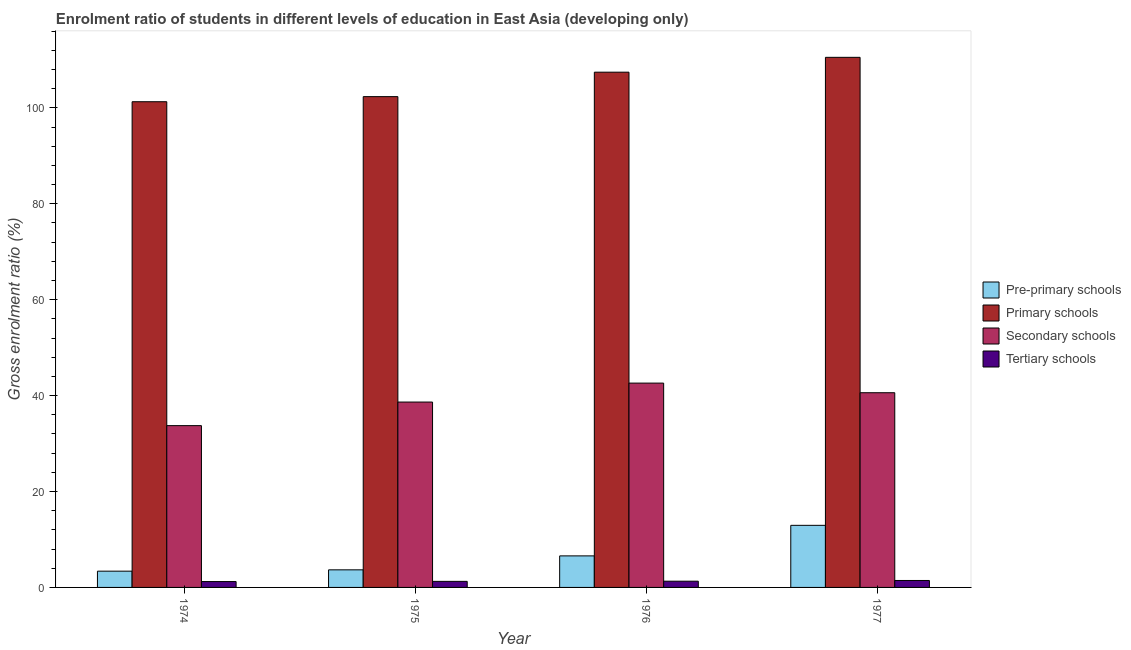How many different coloured bars are there?
Make the answer very short. 4. How many groups of bars are there?
Make the answer very short. 4. Are the number of bars per tick equal to the number of legend labels?
Ensure brevity in your answer.  Yes. Are the number of bars on each tick of the X-axis equal?
Your answer should be very brief. Yes. How many bars are there on the 4th tick from the left?
Provide a succinct answer. 4. What is the label of the 3rd group of bars from the left?
Provide a short and direct response. 1976. What is the gross enrolment ratio in pre-primary schools in 1977?
Give a very brief answer. 12.95. Across all years, what is the maximum gross enrolment ratio in tertiary schools?
Keep it short and to the point. 1.45. Across all years, what is the minimum gross enrolment ratio in pre-primary schools?
Keep it short and to the point. 3.39. In which year was the gross enrolment ratio in primary schools minimum?
Ensure brevity in your answer.  1974. What is the total gross enrolment ratio in pre-primary schools in the graph?
Provide a succinct answer. 26.59. What is the difference between the gross enrolment ratio in primary schools in 1975 and that in 1976?
Make the answer very short. -5.1. What is the difference between the gross enrolment ratio in tertiary schools in 1977 and the gross enrolment ratio in primary schools in 1975?
Ensure brevity in your answer.  0.19. What is the average gross enrolment ratio in pre-primary schools per year?
Offer a very short reply. 6.65. In how many years, is the gross enrolment ratio in primary schools greater than 88 %?
Provide a short and direct response. 4. What is the ratio of the gross enrolment ratio in primary schools in 1974 to that in 1977?
Provide a short and direct response. 0.92. Is the gross enrolment ratio in secondary schools in 1974 less than that in 1976?
Give a very brief answer. Yes. What is the difference between the highest and the second highest gross enrolment ratio in pre-primary schools?
Your response must be concise. 6.37. What is the difference between the highest and the lowest gross enrolment ratio in tertiary schools?
Your response must be concise. 0.22. Is the sum of the gross enrolment ratio in pre-primary schools in 1976 and 1977 greater than the maximum gross enrolment ratio in secondary schools across all years?
Ensure brevity in your answer.  Yes. Is it the case that in every year, the sum of the gross enrolment ratio in pre-primary schools and gross enrolment ratio in primary schools is greater than the sum of gross enrolment ratio in tertiary schools and gross enrolment ratio in secondary schools?
Provide a short and direct response. No. What does the 2nd bar from the left in 1977 represents?
Ensure brevity in your answer.  Primary schools. What does the 2nd bar from the right in 1974 represents?
Your answer should be very brief. Secondary schools. Is it the case that in every year, the sum of the gross enrolment ratio in pre-primary schools and gross enrolment ratio in primary schools is greater than the gross enrolment ratio in secondary schools?
Ensure brevity in your answer.  Yes. What is the difference between two consecutive major ticks on the Y-axis?
Make the answer very short. 20. Where does the legend appear in the graph?
Provide a succinct answer. Center right. How are the legend labels stacked?
Provide a succinct answer. Vertical. What is the title of the graph?
Your answer should be very brief. Enrolment ratio of students in different levels of education in East Asia (developing only). Does "Structural Policies" appear as one of the legend labels in the graph?
Provide a short and direct response. No. What is the label or title of the Y-axis?
Provide a short and direct response. Gross enrolment ratio (%). What is the Gross enrolment ratio (%) in Pre-primary schools in 1974?
Make the answer very short. 3.39. What is the Gross enrolment ratio (%) of Primary schools in 1974?
Your response must be concise. 101.29. What is the Gross enrolment ratio (%) in Secondary schools in 1974?
Keep it short and to the point. 33.74. What is the Gross enrolment ratio (%) in Tertiary schools in 1974?
Your answer should be very brief. 1.22. What is the Gross enrolment ratio (%) of Pre-primary schools in 1975?
Provide a short and direct response. 3.67. What is the Gross enrolment ratio (%) in Primary schools in 1975?
Provide a succinct answer. 102.35. What is the Gross enrolment ratio (%) in Secondary schools in 1975?
Your answer should be compact. 38.66. What is the Gross enrolment ratio (%) in Tertiary schools in 1975?
Keep it short and to the point. 1.26. What is the Gross enrolment ratio (%) of Pre-primary schools in 1976?
Provide a succinct answer. 6.58. What is the Gross enrolment ratio (%) in Primary schools in 1976?
Make the answer very short. 107.45. What is the Gross enrolment ratio (%) in Secondary schools in 1976?
Provide a short and direct response. 42.61. What is the Gross enrolment ratio (%) in Tertiary schools in 1976?
Offer a terse response. 1.3. What is the Gross enrolment ratio (%) of Pre-primary schools in 1977?
Offer a terse response. 12.95. What is the Gross enrolment ratio (%) of Primary schools in 1977?
Make the answer very short. 110.55. What is the Gross enrolment ratio (%) of Secondary schools in 1977?
Provide a succinct answer. 40.6. What is the Gross enrolment ratio (%) in Tertiary schools in 1977?
Ensure brevity in your answer.  1.45. Across all years, what is the maximum Gross enrolment ratio (%) of Pre-primary schools?
Provide a succinct answer. 12.95. Across all years, what is the maximum Gross enrolment ratio (%) in Primary schools?
Provide a short and direct response. 110.55. Across all years, what is the maximum Gross enrolment ratio (%) of Secondary schools?
Your answer should be very brief. 42.61. Across all years, what is the maximum Gross enrolment ratio (%) of Tertiary schools?
Offer a very short reply. 1.45. Across all years, what is the minimum Gross enrolment ratio (%) of Pre-primary schools?
Offer a very short reply. 3.39. Across all years, what is the minimum Gross enrolment ratio (%) in Primary schools?
Offer a very short reply. 101.29. Across all years, what is the minimum Gross enrolment ratio (%) of Secondary schools?
Offer a terse response. 33.74. Across all years, what is the minimum Gross enrolment ratio (%) of Tertiary schools?
Ensure brevity in your answer.  1.22. What is the total Gross enrolment ratio (%) in Pre-primary schools in the graph?
Provide a succinct answer. 26.59. What is the total Gross enrolment ratio (%) in Primary schools in the graph?
Give a very brief answer. 421.64. What is the total Gross enrolment ratio (%) of Secondary schools in the graph?
Your answer should be compact. 155.61. What is the total Gross enrolment ratio (%) in Tertiary schools in the graph?
Give a very brief answer. 5.24. What is the difference between the Gross enrolment ratio (%) of Pre-primary schools in 1974 and that in 1975?
Keep it short and to the point. -0.28. What is the difference between the Gross enrolment ratio (%) in Primary schools in 1974 and that in 1975?
Your response must be concise. -1.06. What is the difference between the Gross enrolment ratio (%) of Secondary schools in 1974 and that in 1975?
Provide a short and direct response. -4.92. What is the difference between the Gross enrolment ratio (%) of Tertiary schools in 1974 and that in 1975?
Make the answer very short. -0.04. What is the difference between the Gross enrolment ratio (%) in Pre-primary schools in 1974 and that in 1976?
Offer a terse response. -3.19. What is the difference between the Gross enrolment ratio (%) of Primary schools in 1974 and that in 1976?
Offer a terse response. -6.16. What is the difference between the Gross enrolment ratio (%) of Secondary schools in 1974 and that in 1976?
Your response must be concise. -8.87. What is the difference between the Gross enrolment ratio (%) in Tertiary schools in 1974 and that in 1976?
Ensure brevity in your answer.  -0.07. What is the difference between the Gross enrolment ratio (%) in Pre-primary schools in 1974 and that in 1977?
Provide a short and direct response. -9.56. What is the difference between the Gross enrolment ratio (%) of Primary schools in 1974 and that in 1977?
Provide a succinct answer. -9.26. What is the difference between the Gross enrolment ratio (%) of Secondary schools in 1974 and that in 1977?
Your answer should be very brief. -6.86. What is the difference between the Gross enrolment ratio (%) in Tertiary schools in 1974 and that in 1977?
Offer a very short reply. -0.22. What is the difference between the Gross enrolment ratio (%) of Pre-primary schools in 1975 and that in 1976?
Keep it short and to the point. -2.91. What is the difference between the Gross enrolment ratio (%) in Secondary schools in 1975 and that in 1976?
Your answer should be very brief. -3.95. What is the difference between the Gross enrolment ratio (%) in Tertiary schools in 1975 and that in 1976?
Ensure brevity in your answer.  -0.04. What is the difference between the Gross enrolment ratio (%) in Pre-primary schools in 1975 and that in 1977?
Offer a very short reply. -9.28. What is the difference between the Gross enrolment ratio (%) in Primary schools in 1975 and that in 1977?
Offer a very short reply. -8.2. What is the difference between the Gross enrolment ratio (%) in Secondary schools in 1975 and that in 1977?
Give a very brief answer. -1.95. What is the difference between the Gross enrolment ratio (%) of Tertiary schools in 1975 and that in 1977?
Your answer should be very brief. -0.19. What is the difference between the Gross enrolment ratio (%) of Pre-primary schools in 1976 and that in 1977?
Provide a short and direct response. -6.37. What is the difference between the Gross enrolment ratio (%) in Primary schools in 1976 and that in 1977?
Keep it short and to the point. -3.1. What is the difference between the Gross enrolment ratio (%) in Secondary schools in 1976 and that in 1977?
Your answer should be very brief. 2. What is the difference between the Gross enrolment ratio (%) of Tertiary schools in 1976 and that in 1977?
Give a very brief answer. -0.15. What is the difference between the Gross enrolment ratio (%) in Pre-primary schools in 1974 and the Gross enrolment ratio (%) in Primary schools in 1975?
Make the answer very short. -98.96. What is the difference between the Gross enrolment ratio (%) in Pre-primary schools in 1974 and the Gross enrolment ratio (%) in Secondary schools in 1975?
Provide a succinct answer. -35.27. What is the difference between the Gross enrolment ratio (%) in Pre-primary schools in 1974 and the Gross enrolment ratio (%) in Tertiary schools in 1975?
Make the answer very short. 2.13. What is the difference between the Gross enrolment ratio (%) in Primary schools in 1974 and the Gross enrolment ratio (%) in Secondary schools in 1975?
Your answer should be very brief. 62.63. What is the difference between the Gross enrolment ratio (%) in Primary schools in 1974 and the Gross enrolment ratio (%) in Tertiary schools in 1975?
Make the answer very short. 100.02. What is the difference between the Gross enrolment ratio (%) of Secondary schools in 1974 and the Gross enrolment ratio (%) of Tertiary schools in 1975?
Your response must be concise. 32.48. What is the difference between the Gross enrolment ratio (%) of Pre-primary schools in 1974 and the Gross enrolment ratio (%) of Primary schools in 1976?
Ensure brevity in your answer.  -104.06. What is the difference between the Gross enrolment ratio (%) of Pre-primary schools in 1974 and the Gross enrolment ratio (%) of Secondary schools in 1976?
Ensure brevity in your answer.  -39.22. What is the difference between the Gross enrolment ratio (%) of Pre-primary schools in 1974 and the Gross enrolment ratio (%) of Tertiary schools in 1976?
Your answer should be compact. 2.09. What is the difference between the Gross enrolment ratio (%) in Primary schools in 1974 and the Gross enrolment ratio (%) in Secondary schools in 1976?
Your answer should be compact. 58.68. What is the difference between the Gross enrolment ratio (%) in Primary schools in 1974 and the Gross enrolment ratio (%) in Tertiary schools in 1976?
Your answer should be very brief. 99.99. What is the difference between the Gross enrolment ratio (%) in Secondary schools in 1974 and the Gross enrolment ratio (%) in Tertiary schools in 1976?
Your answer should be compact. 32.44. What is the difference between the Gross enrolment ratio (%) of Pre-primary schools in 1974 and the Gross enrolment ratio (%) of Primary schools in 1977?
Offer a terse response. -107.16. What is the difference between the Gross enrolment ratio (%) in Pre-primary schools in 1974 and the Gross enrolment ratio (%) in Secondary schools in 1977?
Your answer should be compact. -37.21. What is the difference between the Gross enrolment ratio (%) in Pre-primary schools in 1974 and the Gross enrolment ratio (%) in Tertiary schools in 1977?
Your answer should be compact. 1.94. What is the difference between the Gross enrolment ratio (%) of Primary schools in 1974 and the Gross enrolment ratio (%) of Secondary schools in 1977?
Give a very brief answer. 60.68. What is the difference between the Gross enrolment ratio (%) in Primary schools in 1974 and the Gross enrolment ratio (%) in Tertiary schools in 1977?
Ensure brevity in your answer.  99.84. What is the difference between the Gross enrolment ratio (%) of Secondary schools in 1974 and the Gross enrolment ratio (%) of Tertiary schools in 1977?
Your answer should be very brief. 32.29. What is the difference between the Gross enrolment ratio (%) in Pre-primary schools in 1975 and the Gross enrolment ratio (%) in Primary schools in 1976?
Make the answer very short. -103.78. What is the difference between the Gross enrolment ratio (%) in Pre-primary schools in 1975 and the Gross enrolment ratio (%) in Secondary schools in 1976?
Keep it short and to the point. -38.94. What is the difference between the Gross enrolment ratio (%) of Pre-primary schools in 1975 and the Gross enrolment ratio (%) of Tertiary schools in 1976?
Provide a short and direct response. 2.37. What is the difference between the Gross enrolment ratio (%) in Primary schools in 1975 and the Gross enrolment ratio (%) in Secondary schools in 1976?
Make the answer very short. 59.74. What is the difference between the Gross enrolment ratio (%) in Primary schools in 1975 and the Gross enrolment ratio (%) in Tertiary schools in 1976?
Make the answer very short. 101.05. What is the difference between the Gross enrolment ratio (%) of Secondary schools in 1975 and the Gross enrolment ratio (%) of Tertiary schools in 1976?
Make the answer very short. 37.36. What is the difference between the Gross enrolment ratio (%) in Pre-primary schools in 1975 and the Gross enrolment ratio (%) in Primary schools in 1977?
Ensure brevity in your answer.  -106.88. What is the difference between the Gross enrolment ratio (%) in Pre-primary schools in 1975 and the Gross enrolment ratio (%) in Secondary schools in 1977?
Provide a short and direct response. -36.93. What is the difference between the Gross enrolment ratio (%) in Pre-primary schools in 1975 and the Gross enrolment ratio (%) in Tertiary schools in 1977?
Give a very brief answer. 2.22. What is the difference between the Gross enrolment ratio (%) of Primary schools in 1975 and the Gross enrolment ratio (%) of Secondary schools in 1977?
Your answer should be very brief. 61.75. What is the difference between the Gross enrolment ratio (%) in Primary schools in 1975 and the Gross enrolment ratio (%) in Tertiary schools in 1977?
Offer a terse response. 100.9. What is the difference between the Gross enrolment ratio (%) in Secondary schools in 1975 and the Gross enrolment ratio (%) in Tertiary schools in 1977?
Your answer should be compact. 37.21. What is the difference between the Gross enrolment ratio (%) in Pre-primary schools in 1976 and the Gross enrolment ratio (%) in Primary schools in 1977?
Provide a succinct answer. -103.97. What is the difference between the Gross enrolment ratio (%) of Pre-primary schools in 1976 and the Gross enrolment ratio (%) of Secondary schools in 1977?
Ensure brevity in your answer.  -34.03. What is the difference between the Gross enrolment ratio (%) of Pre-primary schools in 1976 and the Gross enrolment ratio (%) of Tertiary schools in 1977?
Offer a terse response. 5.13. What is the difference between the Gross enrolment ratio (%) in Primary schools in 1976 and the Gross enrolment ratio (%) in Secondary schools in 1977?
Your answer should be compact. 66.85. What is the difference between the Gross enrolment ratio (%) of Primary schools in 1976 and the Gross enrolment ratio (%) of Tertiary schools in 1977?
Your answer should be compact. 106. What is the difference between the Gross enrolment ratio (%) in Secondary schools in 1976 and the Gross enrolment ratio (%) in Tertiary schools in 1977?
Offer a terse response. 41.16. What is the average Gross enrolment ratio (%) of Pre-primary schools per year?
Provide a short and direct response. 6.65. What is the average Gross enrolment ratio (%) in Primary schools per year?
Keep it short and to the point. 105.41. What is the average Gross enrolment ratio (%) of Secondary schools per year?
Your response must be concise. 38.9. What is the average Gross enrolment ratio (%) of Tertiary schools per year?
Make the answer very short. 1.31. In the year 1974, what is the difference between the Gross enrolment ratio (%) in Pre-primary schools and Gross enrolment ratio (%) in Primary schools?
Give a very brief answer. -97.9. In the year 1974, what is the difference between the Gross enrolment ratio (%) of Pre-primary schools and Gross enrolment ratio (%) of Secondary schools?
Give a very brief answer. -30.35. In the year 1974, what is the difference between the Gross enrolment ratio (%) of Pre-primary schools and Gross enrolment ratio (%) of Tertiary schools?
Provide a short and direct response. 2.17. In the year 1974, what is the difference between the Gross enrolment ratio (%) of Primary schools and Gross enrolment ratio (%) of Secondary schools?
Your answer should be very brief. 67.55. In the year 1974, what is the difference between the Gross enrolment ratio (%) in Primary schools and Gross enrolment ratio (%) in Tertiary schools?
Your answer should be very brief. 100.06. In the year 1974, what is the difference between the Gross enrolment ratio (%) of Secondary schools and Gross enrolment ratio (%) of Tertiary schools?
Your answer should be compact. 32.52. In the year 1975, what is the difference between the Gross enrolment ratio (%) of Pre-primary schools and Gross enrolment ratio (%) of Primary schools?
Provide a short and direct response. -98.68. In the year 1975, what is the difference between the Gross enrolment ratio (%) in Pre-primary schools and Gross enrolment ratio (%) in Secondary schools?
Your response must be concise. -34.99. In the year 1975, what is the difference between the Gross enrolment ratio (%) in Pre-primary schools and Gross enrolment ratio (%) in Tertiary schools?
Your answer should be compact. 2.41. In the year 1975, what is the difference between the Gross enrolment ratio (%) of Primary schools and Gross enrolment ratio (%) of Secondary schools?
Your answer should be compact. 63.69. In the year 1975, what is the difference between the Gross enrolment ratio (%) of Primary schools and Gross enrolment ratio (%) of Tertiary schools?
Offer a very short reply. 101.09. In the year 1975, what is the difference between the Gross enrolment ratio (%) in Secondary schools and Gross enrolment ratio (%) in Tertiary schools?
Offer a terse response. 37.4. In the year 1976, what is the difference between the Gross enrolment ratio (%) of Pre-primary schools and Gross enrolment ratio (%) of Primary schools?
Keep it short and to the point. -100.87. In the year 1976, what is the difference between the Gross enrolment ratio (%) in Pre-primary schools and Gross enrolment ratio (%) in Secondary schools?
Keep it short and to the point. -36.03. In the year 1976, what is the difference between the Gross enrolment ratio (%) in Pre-primary schools and Gross enrolment ratio (%) in Tertiary schools?
Ensure brevity in your answer.  5.28. In the year 1976, what is the difference between the Gross enrolment ratio (%) in Primary schools and Gross enrolment ratio (%) in Secondary schools?
Keep it short and to the point. 64.84. In the year 1976, what is the difference between the Gross enrolment ratio (%) of Primary schools and Gross enrolment ratio (%) of Tertiary schools?
Your response must be concise. 106.15. In the year 1976, what is the difference between the Gross enrolment ratio (%) of Secondary schools and Gross enrolment ratio (%) of Tertiary schools?
Make the answer very short. 41.31. In the year 1977, what is the difference between the Gross enrolment ratio (%) in Pre-primary schools and Gross enrolment ratio (%) in Primary schools?
Provide a short and direct response. -97.6. In the year 1977, what is the difference between the Gross enrolment ratio (%) of Pre-primary schools and Gross enrolment ratio (%) of Secondary schools?
Offer a very short reply. -27.65. In the year 1977, what is the difference between the Gross enrolment ratio (%) in Pre-primary schools and Gross enrolment ratio (%) in Tertiary schools?
Your response must be concise. 11.5. In the year 1977, what is the difference between the Gross enrolment ratio (%) in Primary schools and Gross enrolment ratio (%) in Secondary schools?
Provide a succinct answer. 69.94. In the year 1977, what is the difference between the Gross enrolment ratio (%) of Primary schools and Gross enrolment ratio (%) of Tertiary schools?
Offer a terse response. 109.1. In the year 1977, what is the difference between the Gross enrolment ratio (%) of Secondary schools and Gross enrolment ratio (%) of Tertiary schools?
Offer a terse response. 39.15. What is the ratio of the Gross enrolment ratio (%) in Pre-primary schools in 1974 to that in 1975?
Your answer should be very brief. 0.92. What is the ratio of the Gross enrolment ratio (%) of Primary schools in 1974 to that in 1975?
Keep it short and to the point. 0.99. What is the ratio of the Gross enrolment ratio (%) of Secondary schools in 1974 to that in 1975?
Make the answer very short. 0.87. What is the ratio of the Gross enrolment ratio (%) of Tertiary schools in 1974 to that in 1975?
Offer a very short reply. 0.97. What is the ratio of the Gross enrolment ratio (%) of Pre-primary schools in 1974 to that in 1976?
Provide a short and direct response. 0.52. What is the ratio of the Gross enrolment ratio (%) of Primary schools in 1974 to that in 1976?
Provide a succinct answer. 0.94. What is the ratio of the Gross enrolment ratio (%) in Secondary schools in 1974 to that in 1976?
Your answer should be very brief. 0.79. What is the ratio of the Gross enrolment ratio (%) of Tertiary schools in 1974 to that in 1976?
Provide a short and direct response. 0.94. What is the ratio of the Gross enrolment ratio (%) of Pre-primary schools in 1974 to that in 1977?
Make the answer very short. 0.26. What is the ratio of the Gross enrolment ratio (%) of Primary schools in 1974 to that in 1977?
Provide a short and direct response. 0.92. What is the ratio of the Gross enrolment ratio (%) of Secondary schools in 1974 to that in 1977?
Keep it short and to the point. 0.83. What is the ratio of the Gross enrolment ratio (%) of Tertiary schools in 1974 to that in 1977?
Ensure brevity in your answer.  0.85. What is the ratio of the Gross enrolment ratio (%) of Pre-primary schools in 1975 to that in 1976?
Make the answer very short. 0.56. What is the ratio of the Gross enrolment ratio (%) in Primary schools in 1975 to that in 1976?
Provide a succinct answer. 0.95. What is the ratio of the Gross enrolment ratio (%) in Secondary schools in 1975 to that in 1976?
Give a very brief answer. 0.91. What is the ratio of the Gross enrolment ratio (%) of Tertiary schools in 1975 to that in 1976?
Give a very brief answer. 0.97. What is the ratio of the Gross enrolment ratio (%) of Pre-primary schools in 1975 to that in 1977?
Your response must be concise. 0.28. What is the ratio of the Gross enrolment ratio (%) of Primary schools in 1975 to that in 1977?
Provide a short and direct response. 0.93. What is the ratio of the Gross enrolment ratio (%) of Secondary schools in 1975 to that in 1977?
Keep it short and to the point. 0.95. What is the ratio of the Gross enrolment ratio (%) of Tertiary schools in 1975 to that in 1977?
Keep it short and to the point. 0.87. What is the ratio of the Gross enrolment ratio (%) in Pre-primary schools in 1976 to that in 1977?
Your answer should be very brief. 0.51. What is the ratio of the Gross enrolment ratio (%) of Secondary schools in 1976 to that in 1977?
Make the answer very short. 1.05. What is the ratio of the Gross enrolment ratio (%) in Tertiary schools in 1976 to that in 1977?
Offer a very short reply. 0.9. What is the difference between the highest and the second highest Gross enrolment ratio (%) in Pre-primary schools?
Offer a very short reply. 6.37. What is the difference between the highest and the second highest Gross enrolment ratio (%) of Primary schools?
Give a very brief answer. 3.1. What is the difference between the highest and the second highest Gross enrolment ratio (%) of Secondary schools?
Keep it short and to the point. 2. What is the difference between the highest and the second highest Gross enrolment ratio (%) of Tertiary schools?
Your answer should be very brief. 0.15. What is the difference between the highest and the lowest Gross enrolment ratio (%) in Pre-primary schools?
Provide a short and direct response. 9.56. What is the difference between the highest and the lowest Gross enrolment ratio (%) in Primary schools?
Provide a succinct answer. 9.26. What is the difference between the highest and the lowest Gross enrolment ratio (%) of Secondary schools?
Ensure brevity in your answer.  8.87. What is the difference between the highest and the lowest Gross enrolment ratio (%) in Tertiary schools?
Offer a very short reply. 0.22. 